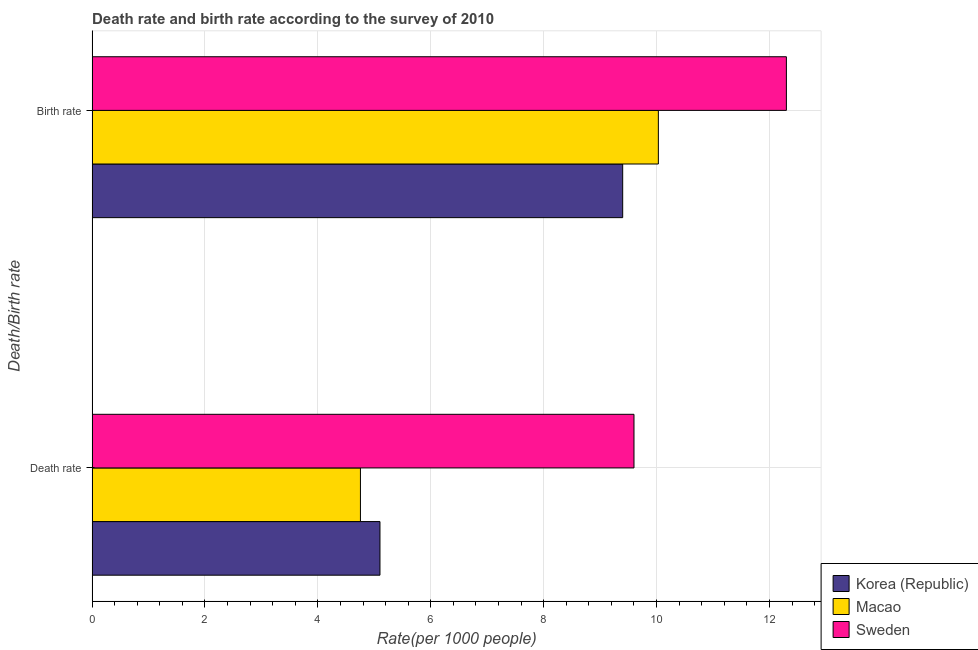How many different coloured bars are there?
Give a very brief answer. 3. How many groups of bars are there?
Your answer should be compact. 2. Are the number of bars on each tick of the Y-axis equal?
Make the answer very short. Yes. How many bars are there on the 2nd tick from the top?
Your response must be concise. 3. How many bars are there on the 1st tick from the bottom?
Make the answer very short. 3. What is the label of the 1st group of bars from the top?
Give a very brief answer. Birth rate. What is the death rate in Macao?
Provide a succinct answer. 4.75. In which country was the death rate minimum?
Offer a terse response. Macao. What is the total death rate in the graph?
Your answer should be very brief. 19.45. What is the difference between the birth rate in Sweden and that in Macao?
Make the answer very short. 2.27. What is the difference between the birth rate in Korea (Republic) and the death rate in Sweden?
Your response must be concise. -0.2. What is the average birth rate per country?
Make the answer very short. 10.58. What is the difference between the birth rate and death rate in Sweden?
Your response must be concise. 2.7. In how many countries, is the birth rate greater than 5.6 ?
Offer a very short reply. 3. What is the ratio of the birth rate in Sweden to that in Korea (Republic)?
Offer a very short reply. 1.31. In how many countries, is the death rate greater than the average death rate taken over all countries?
Provide a short and direct response. 1. What does the 2nd bar from the bottom in Death rate represents?
Make the answer very short. Macao. Are all the bars in the graph horizontal?
Your response must be concise. Yes. What is the difference between two consecutive major ticks on the X-axis?
Ensure brevity in your answer.  2. Does the graph contain any zero values?
Your response must be concise. No. What is the title of the graph?
Your answer should be very brief. Death rate and birth rate according to the survey of 2010. What is the label or title of the X-axis?
Keep it short and to the point. Rate(per 1000 people). What is the label or title of the Y-axis?
Your answer should be compact. Death/Birth rate. What is the Rate(per 1000 people) of Macao in Death rate?
Provide a succinct answer. 4.75. What is the Rate(per 1000 people) of Macao in Birth rate?
Your response must be concise. 10.03. Across all Death/Birth rate, what is the maximum Rate(per 1000 people) of Macao?
Keep it short and to the point. 10.03. Across all Death/Birth rate, what is the minimum Rate(per 1000 people) of Macao?
Provide a succinct answer. 4.75. Across all Death/Birth rate, what is the minimum Rate(per 1000 people) of Sweden?
Your answer should be very brief. 9.6. What is the total Rate(per 1000 people) in Korea (Republic) in the graph?
Give a very brief answer. 14.5. What is the total Rate(per 1000 people) of Macao in the graph?
Offer a terse response. 14.79. What is the total Rate(per 1000 people) of Sweden in the graph?
Provide a succinct answer. 21.9. What is the difference between the Rate(per 1000 people) of Macao in Death rate and that in Birth rate?
Provide a succinct answer. -5.28. What is the difference between the Rate(per 1000 people) in Sweden in Death rate and that in Birth rate?
Your answer should be very brief. -2.7. What is the difference between the Rate(per 1000 people) of Korea (Republic) in Death rate and the Rate(per 1000 people) of Macao in Birth rate?
Offer a very short reply. -4.93. What is the difference between the Rate(per 1000 people) of Korea (Republic) in Death rate and the Rate(per 1000 people) of Sweden in Birth rate?
Your answer should be compact. -7.2. What is the difference between the Rate(per 1000 people) in Macao in Death rate and the Rate(per 1000 people) in Sweden in Birth rate?
Make the answer very short. -7.55. What is the average Rate(per 1000 people) of Korea (Republic) per Death/Birth rate?
Keep it short and to the point. 7.25. What is the average Rate(per 1000 people) in Macao per Death/Birth rate?
Provide a succinct answer. 7.39. What is the average Rate(per 1000 people) in Sweden per Death/Birth rate?
Provide a succinct answer. 10.95. What is the difference between the Rate(per 1000 people) in Korea (Republic) and Rate(per 1000 people) in Macao in Death rate?
Offer a very short reply. 0.35. What is the difference between the Rate(per 1000 people) in Macao and Rate(per 1000 people) in Sweden in Death rate?
Your answer should be compact. -4.85. What is the difference between the Rate(per 1000 people) of Korea (Republic) and Rate(per 1000 people) of Macao in Birth rate?
Provide a succinct answer. -0.63. What is the difference between the Rate(per 1000 people) in Korea (Republic) and Rate(per 1000 people) in Sweden in Birth rate?
Give a very brief answer. -2.9. What is the difference between the Rate(per 1000 people) of Macao and Rate(per 1000 people) of Sweden in Birth rate?
Give a very brief answer. -2.27. What is the ratio of the Rate(per 1000 people) of Korea (Republic) in Death rate to that in Birth rate?
Keep it short and to the point. 0.54. What is the ratio of the Rate(per 1000 people) in Macao in Death rate to that in Birth rate?
Keep it short and to the point. 0.47. What is the ratio of the Rate(per 1000 people) in Sweden in Death rate to that in Birth rate?
Offer a very short reply. 0.78. What is the difference between the highest and the second highest Rate(per 1000 people) of Macao?
Your answer should be compact. 5.28. What is the difference between the highest and the second highest Rate(per 1000 people) of Sweden?
Offer a terse response. 2.7. What is the difference between the highest and the lowest Rate(per 1000 people) in Macao?
Keep it short and to the point. 5.28. 